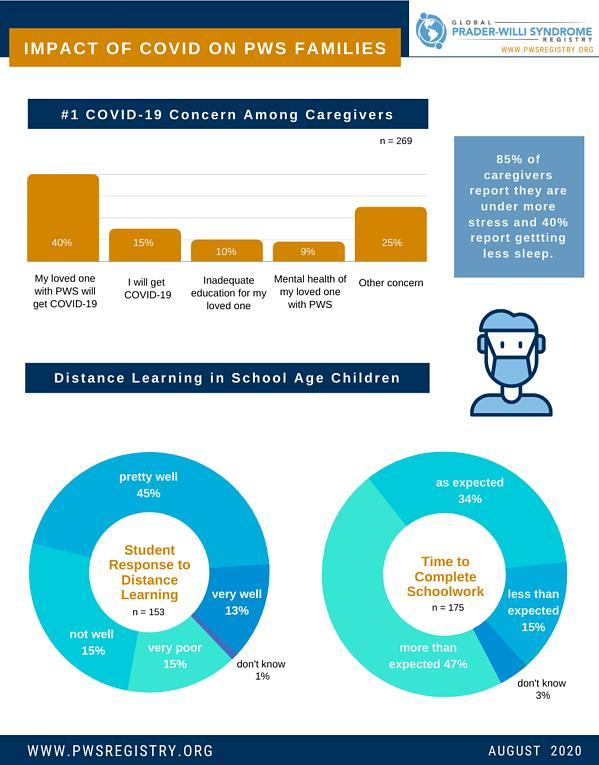What percentage of the school age children has a very well response to distance learning as of August 2020?
Answer the question with a short phrase. 13% What percentage of the school age children has more than the expected time to complete the school work as of August 2020? 47% What percent of the caregivers are concerned that they might get COVID-19 as of August 2020? 15% What percentage of the school age children has a very poor response to distance learning as of August 2020? 15% What percent of the caregivers are concerned about the inadequate education of their loved ones due to the impact of COVID-19 as of August 2020? 10% What percent of the caregivers report that they are concerned  about the mental health of their loved ones with PWS as of August 2020? 9% What percentage of the school age children has less than the expected time to complete the school work as of August 2020? 15% 